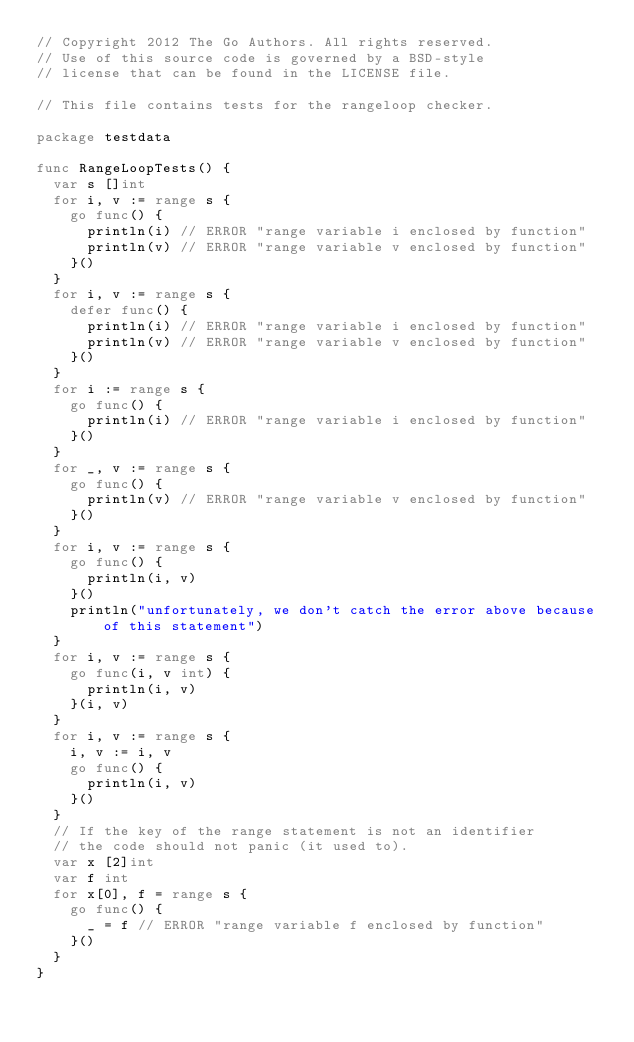<code> <loc_0><loc_0><loc_500><loc_500><_Go_>// Copyright 2012 The Go Authors. All rights reserved.
// Use of this source code is governed by a BSD-style
// license that can be found in the LICENSE file.

// This file contains tests for the rangeloop checker.

package testdata

func RangeLoopTests() {
	var s []int
	for i, v := range s {
		go func() {
			println(i) // ERROR "range variable i enclosed by function"
			println(v) // ERROR "range variable v enclosed by function"
		}()
	}
	for i, v := range s {
		defer func() {
			println(i) // ERROR "range variable i enclosed by function"
			println(v) // ERROR "range variable v enclosed by function"
		}()
	}
	for i := range s {
		go func() {
			println(i) // ERROR "range variable i enclosed by function"
		}()
	}
	for _, v := range s {
		go func() {
			println(v) // ERROR "range variable v enclosed by function"
		}()
	}
	for i, v := range s {
		go func() {
			println(i, v)
		}()
		println("unfortunately, we don't catch the error above because of this statement")
	}
	for i, v := range s {
		go func(i, v int) {
			println(i, v)
		}(i, v)
	}
	for i, v := range s {
		i, v := i, v
		go func() {
			println(i, v)
		}()
	}
	// If the key of the range statement is not an identifier
	// the code should not panic (it used to).
	var x [2]int
	var f int
	for x[0], f = range s {
		go func() {
			_ = f // ERROR "range variable f enclosed by function"
		}()
	}
}
</code> 